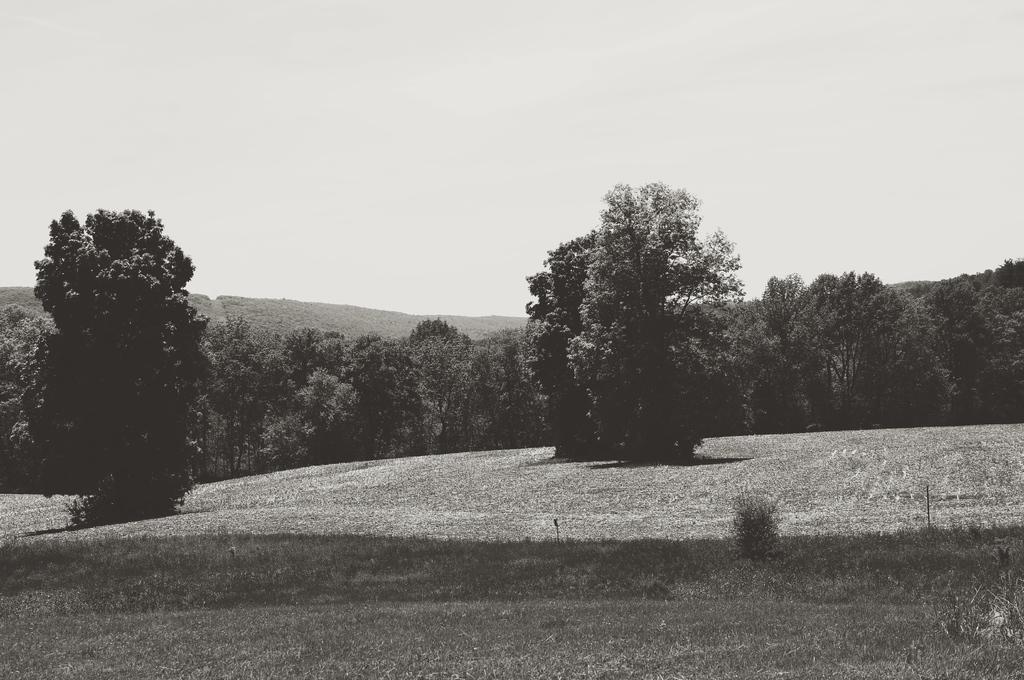Could you give a brief overview of what you see in this image? This is a black and white image. In this image we can see trees, plants, grass and sky. 